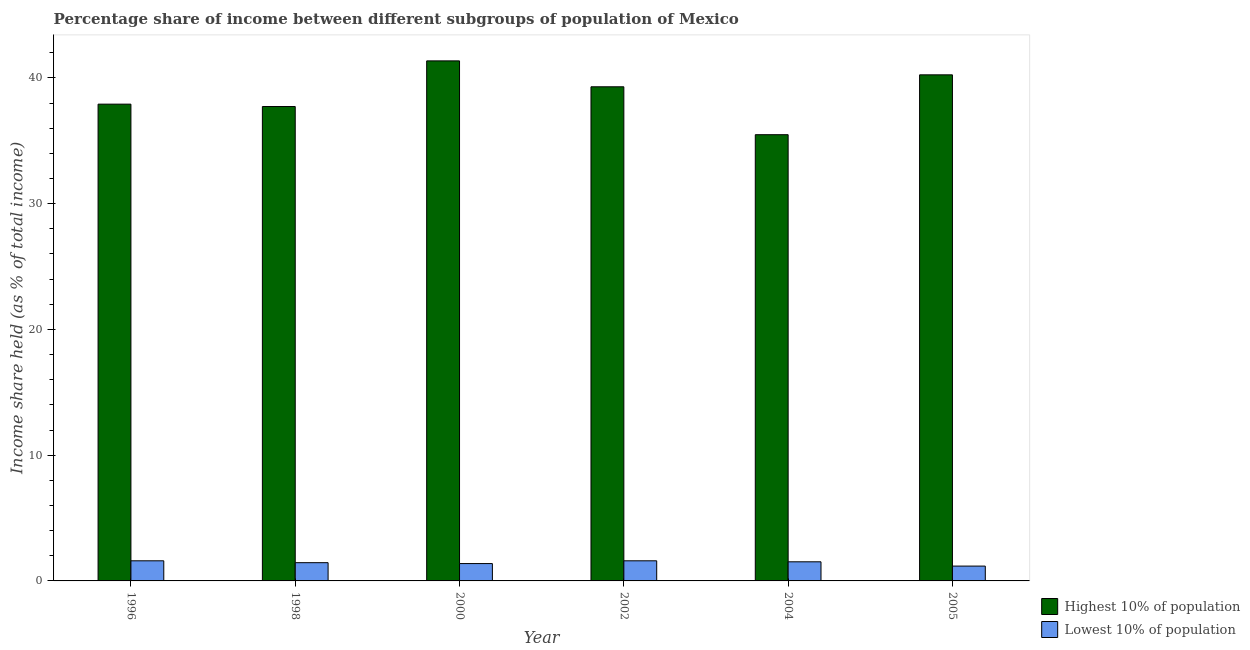How many different coloured bars are there?
Give a very brief answer. 2. Are the number of bars per tick equal to the number of legend labels?
Your answer should be very brief. Yes. Are the number of bars on each tick of the X-axis equal?
Ensure brevity in your answer.  Yes. How many bars are there on the 5th tick from the right?
Give a very brief answer. 2. What is the label of the 1st group of bars from the left?
Ensure brevity in your answer.  1996. What is the income share held by lowest 10% of the population in 2004?
Offer a very short reply. 1.52. Across all years, what is the maximum income share held by highest 10% of the population?
Give a very brief answer. 41.35. Across all years, what is the minimum income share held by lowest 10% of the population?
Make the answer very short. 1.18. In which year was the income share held by highest 10% of the population maximum?
Ensure brevity in your answer.  2000. What is the total income share held by highest 10% of the population in the graph?
Ensure brevity in your answer.  231.99. What is the difference between the income share held by highest 10% of the population in 2000 and that in 2004?
Keep it short and to the point. 5.87. What is the difference between the income share held by highest 10% of the population in 1998 and the income share held by lowest 10% of the population in 2002?
Your answer should be compact. -1.57. What is the average income share held by lowest 10% of the population per year?
Make the answer very short. 1.45. What is the ratio of the income share held by lowest 10% of the population in 2002 to that in 2004?
Offer a very short reply. 1.05. Is the income share held by highest 10% of the population in 1998 less than that in 2002?
Keep it short and to the point. Yes. Is the difference between the income share held by highest 10% of the population in 1998 and 2002 greater than the difference between the income share held by lowest 10% of the population in 1998 and 2002?
Ensure brevity in your answer.  No. What is the difference between the highest and the second highest income share held by highest 10% of the population?
Provide a succinct answer. 1.11. What is the difference between the highest and the lowest income share held by lowest 10% of the population?
Your answer should be very brief. 0.42. What does the 2nd bar from the left in 2004 represents?
Your answer should be very brief. Lowest 10% of population. What does the 2nd bar from the right in 2000 represents?
Provide a succinct answer. Highest 10% of population. How many bars are there?
Give a very brief answer. 12. How many years are there in the graph?
Your answer should be very brief. 6. What is the difference between two consecutive major ticks on the Y-axis?
Provide a succinct answer. 10. Does the graph contain any zero values?
Your answer should be very brief. No. Does the graph contain grids?
Your answer should be very brief. No. Where does the legend appear in the graph?
Ensure brevity in your answer.  Bottom right. How many legend labels are there?
Keep it short and to the point. 2. What is the title of the graph?
Your answer should be compact. Percentage share of income between different subgroups of population of Mexico. What is the label or title of the X-axis?
Your answer should be very brief. Year. What is the label or title of the Y-axis?
Ensure brevity in your answer.  Income share held (as % of total income). What is the Income share held (as % of total income) of Highest 10% of population in 1996?
Keep it short and to the point. 37.91. What is the Income share held (as % of total income) in Highest 10% of population in 1998?
Provide a succinct answer. 37.72. What is the Income share held (as % of total income) in Lowest 10% of population in 1998?
Provide a short and direct response. 1.45. What is the Income share held (as % of total income) in Highest 10% of population in 2000?
Give a very brief answer. 41.35. What is the Income share held (as % of total income) of Lowest 10% of population in 2000?
Offer a terse response. 1.38. What is the Income share held (as % of total income) in Highest 10% of population in 2002?
Ensure brevity in your answer.  39.29. What is the Income share held (as % of total income) in Lowest 10% of population in 2002?
Offer a terse response. 1.6. What is the Income share held (as % of total income) in Highest 10% of population in 2004?
Provide a short and direct response. 35.48. What is the Income share held (as % of total income) in Lowest 10% of population in 2004?
Offer a terse response. 1.52. What is the Income share held (as % of total income) of Highest 10% of population in 2005?
Make the answer very short. 40.24. What is the Income share held (as % of total income) of Lowest 10% of population in 2005?
Your response must be concise. 1.18. Across all years, what is the maximum Income share held (as % of total income) in Highest 10% of population?
Keep it short and to the point. 41.35. Across all years, what is the minimum Income share held (as % of total income) of Highest 10% of population?
Make the answer very short. 35.48. Across all years, what is the minimum Income share held (as % of total income) of Lowest 10% of population?
Your response must be concise. 1.18. What is the total Income share held (as % of total income) of Highest 10% of population in the graph?
Your answer should be compact. 231.99. What is the total Income share held (as % of total income) of Lowest 10% of population in the graph?
Give a very brief answer. 8.73. What is the difference between the Income share held (as % of total income) of Highest 10% of population in 1996 and that in 1998?
Provide a short and direct response. 0.19. What is the difference between the Income share held (as % of total income) in Lowest 10% of population in 1996 and that in 1998?
Offer a very short reply. 0.15. What is the difference between the Income share held (as % of total income) in Highest 10% of population in 1996 and that in 2000?
Provide a succinct answer. -3.44. What is the difference between the Income share held (as % of total income) of Lowest 10% of population in 1996 and that in 2000?
Keep it short and to the point. 0.22. What is the difference between the Income share held (as % of total income) of Highest 10% of population in 1996 and that in 2002?
Ensure brevity in your answer.  -1.38. What is the difference between the Income share held (as % of total income) in Highest 10% of population in 1996 and that in 2004?
Make the answer very short. 2.43. What is the difference between the Income share held (as % of total income) in Highest 10% of population in 1996 and that in 2005?
Ensure brevity in your answer.  -2.33. What is the difference between the Income share held (as % of total income) of Lowest 10% of population in 1996 and that in 2005?
Your answer should be very brief. 0.42. What is the difference between the Income share held (as % of total income) of Highest 10% of population in 1998 and that in 2000?
Your answer should be very brief. -3.63. What is the difference between the Income share held (as % of total income) of Lowest 10% of population in 1998 and that in 2000?
Offer a terse response. 0.07. What is the difference between the Income share held (as % of total income) of Highest 10% of population in 1998 and that in 2002?
Your answer should be very brief. -1.57. What is the difference between the Income share held (as % of total income) in Highest 10% of population in 1998 and that in 2004?
Make the answer very short. 2.24. What is the difference between the Income share held (as % of total income) of Lowest 10% of population in 1998 and that in 2004?
Your response must be concise. -0.07. What is the difference between the Income share held (as % of total income) in Highest 10% of population in 1998 and that in 2005?
Keep it short and to the point. -2.52. What is the difference between the Income share held (as % of total income) in Lowest 10% of population in 1998 and that in 2005?
Offer a very short reply. 0.27. What is the difference between the Income share held (as % of total income) in Highest 10% of population in 2000 and that in 2002?
Give a very brief answer. 2.06. What is the difference between the Income share held (as % of total income) in Lowest 10% of population in 2000 and that in 2002?
Offer a terse response. -0.22. What is the difference between the Income share held (as % of total income) in Highest 10% of population in 2000 and that in 2004?
Offer a very short reply. 5.87. What is the difference between the Income share held (as % of total income) in Lowest 10% of population in 2000 and that in 2004?
Offer a very short reply. -0.14. What is the difference between the Income share held (as % of total income) of Highest 10% of population in 2000 and that in 2005?
Offer a terse response. 1.11. What is the difference between the Income share held (as % of total income) in Highest 10% of population in 2002 and that in 2004?
Make the answer very short. 3.81. What is the difference between the Income share held (as % of total income) of Highest 10% of population in 2002 and that in 2005?
Provide a succinct answer. -0.95. What is the difference between the Income share held (as % of total income) in Lowest 10% of population in 2002 and that in 2005?
Offer a terse response. 0.42. What is the difference between the Income share held (as % of total income) in Highest 10% of population in 2004 and that in 2005?
Offer a very short reply. -4.76. What is the difference between the Income share held (as % of total income) in Lowest 10% of population in 2004 and that in 2005?
Give a very brief answer. 0.34. What is the difference between the Income share held (as % of total income) of Highest 10% of population in 1996 and the Income share held (as % of total income) of Lowest 10% of population in 1998?
Your response must be concise. 36.46. What is the difference between the Income share held (as % of total income) of Highest 10% of population in 1996 and the Income share held (as % of total income) of Lowest 10% of population in 2000?
Give a very brief answer. 36.53. What is the difference between the Income share held (as % of total income) in Highest 10% of population in 1996 and the Income share held (as % of total income) in Lowest 10% of population in 2002?
Your response must be concise. 36.31. What is the difference between the Income share held (as % of total income) in Highest 10% of population in 1996 and the Income share held (as % of total income) in Lowest 10% of population in 2004?
Your answer should be compact. 36.39. What is the difference between the Income share held (as % of total income) of Highest 10% of population in 1996 and the Income share held (as % of total income) of Lowest 10% of population in 2005?
Ensure brevity in your answer.  36.73. What is the difference between the Income share held (as % of total income) of Highest 10% of population in 1998 and the Income share held (as % of total income) of Lowest 10% of population in 2000?
Offer a terse response. 36.34. What is the difference between the Income share held (as % of total income) in Highest 10% of population in 1998 and the Income share held (as % of total income) in Lowest 10% of population in 2002?
Your answer should be compact. 36.12. What is the difference between the Income share held (as % of total income) of Highest 10% of population in 1998 and the Income share held (as % of total income) of Lowest 10% of population in 2004?
Give a very brief answer. 36.2. What is the difference between the Income share held (as % of total income) of Highest 10% of population in 1998 and the Income share held (as % of total income) of Lowest 10% of population in 2005?
Make the answer very short. 36.54. What is the difference between the Income share held (as % of total income) of Highest 10% of population in 2000 and the Income share held (as % of total income) of Lowest 10% of population in 2002?
Offer a terse response. 39.75. What is the difference between the Income share held (as % of total income) in Highest 10% of population in 2000 and the Income share held (as % of total income) in Lowest 10% of population in 2004?
Give a very brief answer. 39.83. What is the difference between the Income share held (as % of total income) of Highest 10% of population in 2000 and the Income share held (as % of total income) of Lowest 10% of population in 2005?
Offer a terse response. 40.17. What is the difference between the Income share held (as % of total income) in Highest 10% of population in 2002 and the Income share held (as % of total income) in Lowest 10% of population in 2004?
Your response must be concise. 37.77. What is the difference between the Income share held (as % of total income) of Highest 10% of population in 2002 and the Income share held (as % of total income) of Lowest 10% of population in 2005?
Make the answer very short. 38.11. What is the difference between the Income share held (as % of total income) in Highest 10% of population in 2004 and the Income share held (as % of total income) in Lowest 10% of population in 2005?
Provide a short and direct response. 34.3. What is the average Income share held (as % of total income) in Highest 10% of population per year?
Offer a terse response. 38.66. What is the average Income share held (as % of total income) of Lowest 10% of population per year?
Your response must be concise. 1.46. In the year 1996, what is the difference between the Income share held (as % of total income) of Highest 10% of population and Income share held (as % of total income) of Lowest 10% of population?
Make the answer very short. 36.31. In the year 1998, what is the difference between the Income share held (as % of total income) of Highest 10% of population and Income share held (as % of total income) of Lowest 10% of population?
Provide a short and direct response. 36.27. In the year 2000, what is the difference between the Income share held (as % of total income) of Highest 10% of population and Income share held (as % of total income) of Lowest 10% of population?
Provide a short and direct response. 39.97. In the year 2002, what is the difference between the Income share held (as % of total income) of Highest 10% of population and Income share held (as % of total income) of Lowest 10% of population?
Your response must be concise. 37.69. In the year 2004, what is the difference between the Income share held (as % of total income) in Highest 10% of population and Income share held (as % of total income) in Lowest 10% of population?
Keep it short and to the point. 33.96. In the year 2005, what is the difference between the Income share held (as % of total income) in Highest 10% of population and Income share held (as % of total income) in Lowest 10% of population?
Make the answer very short. 39.06. What is the ratio of the Income share held (as % of total income) in Highest 10% of population in 1996 to that in 1998?
Keep it short and to the point. 1. What is the ratio of the Income share held (as % of total income) in Lowest 10% of population in 1996 to that in 1998?
Your response must be concise. 1.1. What is the ratio of the Income share held (as % of total income) in Highest 10% of population in 1996 to that in 2000?
Offer a terse response. 0.92. What is the ratio of the Income share held (as % of total income) in Lowest 10% of population in 1996 to that in 2000?
Give a very brief answer. 1.16. What is the ratio of the Income share held (as % of total income) in Highest 10% of population in 1996 to that in 2002?
Your response must be concise. 0.96. What is the ratio of the Income share held (as % of total income) of Lowest 10% of population in 1996 to that in 2002?
Your response must be concise. 1. What is the ratio of the Income share held (as % of total income) in Highest 10% of population in 1996 to that in 2004?
Make the answer very short. 1.07. What is the ratio of the Income share held (as % of total income) in Lowest 10% of population in 1996 to that in 2004?
Keep it short and to the point. 1.05. What is the ratio of the Income share held (as % of total income) of Highest 10% of population in 1996 to that in 2005?
Your answer should be very brief. 0.94. What is the ratio of the Income share held (as % of total income) of Lowest 10% of population in 1996 to that in 2005?
Your answer should be very brief. 1.36. What is the ratio of the Income share held (as % of total income) of Highest 10% of population in 1998 to that in 2000?
Give a very brief answer. 0.91. What is the ratio of the Income share held (as % of total income) in Lowest 10% of population in 1998 to that in 2000?
Your answer should be very brief. 1.05. What is the ratio of the Income share held (as % of total income) of Lowest 10% of population in 1998 to that in 2002?
Provide a succinct answer. 0.91. What is the ratio of the Income share held (as % of total income) of Highest 10% of population in 1998 to that in 2004?
Offer a very short reply. 1.06. What is the ratio of the Income share held (as % of total income) of Lowest 10% of population in 1998 to that in 2004?
Make the answer very short. 0.95. What is the ratio of the Income share held (as % of total income) in Highest 10% of population in 1998 to that in 2005?
Your response must be concise. 0.94. What is the ratio of the Income share held (as % of total income) of Lowest 10% of population in 1998 to that in 2005?
Make the answer very short. 1.23. What is the ratio of the Income share held (as % of total income) of Highest 10% of population in 2000 to that in 2002?
Keep it short and to the point. 1.05. What is the ratio of the Income share held (as % of total income) of Lowest 10% of population in 2000 to that in 2002?
Your answer should be very brief. 0.86. What is the ratio of the Income share held (as % of total income) of Highest 10% of population in 2000 to that in 2004?
Offer a terse response. 1.17. What is the ratio of the Income share held (as % of total income) of Lowest 10% of population in 2000 to that in 2004?
Offer a terse response. 0.91. What is the ratio of the Income share held (as % of total income) in Highest 10% of population in 2000 to that in 2005?
Keep it short and to the point. 1.03. What is the ratio of the Income share held (as % of total income) of Lowest 10% of population in 2000 to that in 2005?
Your answer should be very brief. 1.17. What is the ratio of the Income share held (as % of total income) in Highest 10% of population in 2002 to that in 2004?
Ensure brevity in your answer.  1.11. What is the ratio of the Income share held (as % of total income) in Lowest 10% of population in 2002 to that in 2004?
Provide a succinct answer. 1.05. What is the ratio of the Income share held (as % of total income) in Highest 10% of population in 2002 to that in 2005?
Give a very brief answer. 0.98. What is the ratio of the Income share held (as % of total income) in Lowest 10% of population in 2002 to that in 2005?
Your answer should be compact. 1.36. What is the ratio of the Income share held (as % of total income) in Highest 10% of population in 2004 to that in 2005?
Give a very brief answer. 0.88. What is the ratio of the Income share held (as % of total income) in Lowest 10% of population in 2004 to that in 2005?
Your answer should be very brief. 1.29. What is the difference between the highest and the second highest Income share held (as % of total income) in Highest 10% of population?
Offer a very short reply. 1.11. What is the difference between the highest and the second highest Income share held (as % of total income) of Lowest 10% of population?
Your answer should be compact. 0. What is the difference between the highest and the lowest Income share held (as % of total income) in Highest 10% of population?
Keep it short and to the point. 5.87. What is the difference between the highest and the lowest Income share held (as % of total income) in Lowest 10% of population?
Your answer should be compact. 0.42. 